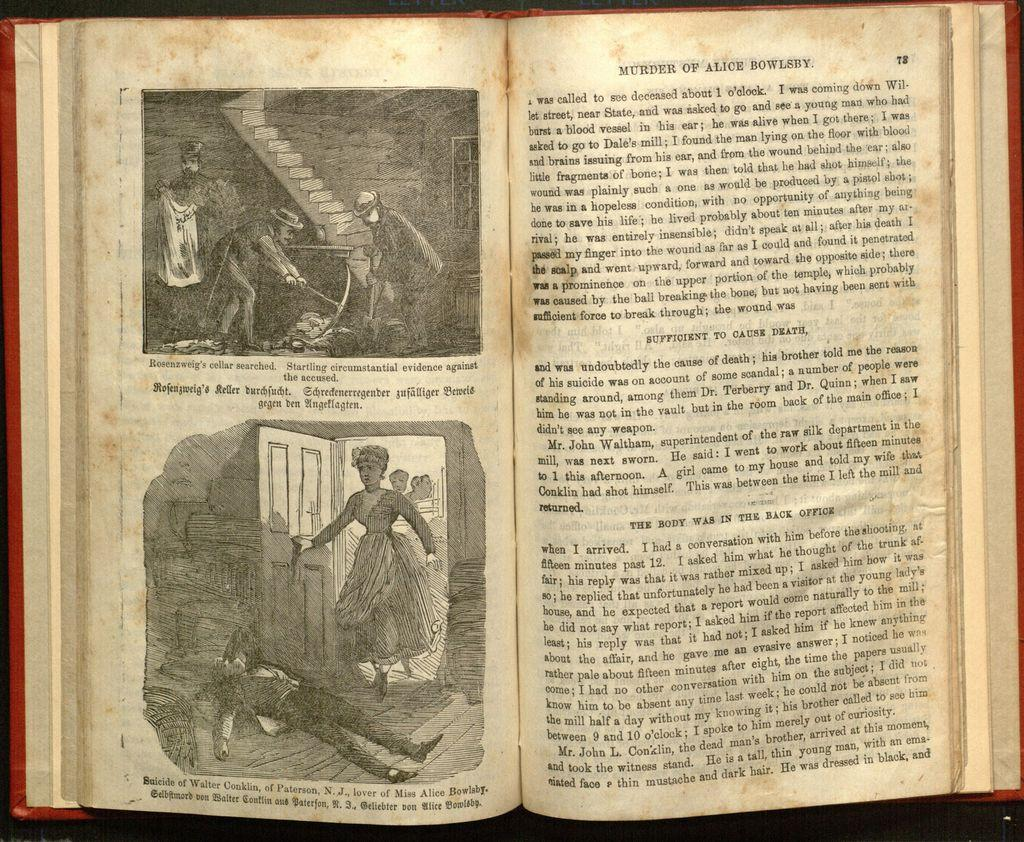<image>
Share a concise interpretation of the image provided. a book that is about a Murder of Alice Bowlsby 